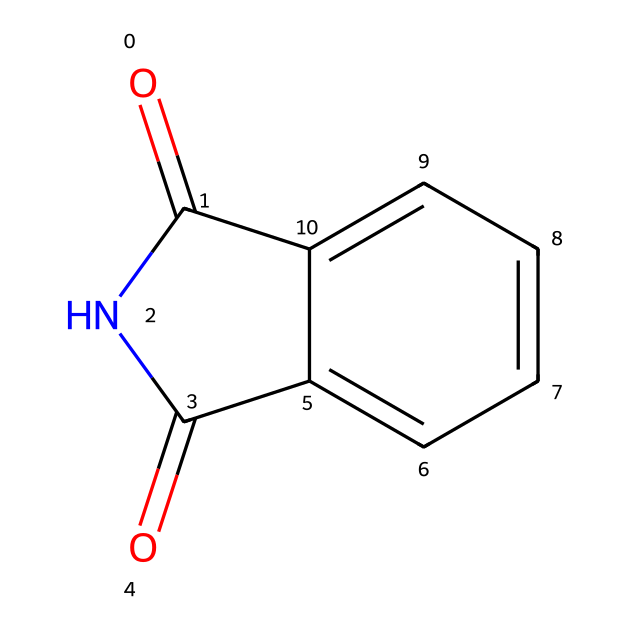What is the molecular formula of phthalimide? By analyzing the structure from the SMILES representation, O=C1NC(=O)c2ccccc21, we can count the atoms: there are 8 carbon (C), 5 hydrogen (H), 2 nitrogen (N), and 2 oxygen (O) atoms, leading to a formula of C8H5N2O2.
Answer: C8H5N2O2 How many rings are present in the structure? The structure indicates that there are two fused rings: the five-membered imide ring and the phenyl ring, which is a six-membered ring. This is evident from the connectivity indicated in the SMILES representation.
Answer: 2 What functional groups are present in phthalimide? Distinct functional groups identified in the structure include the imide (C=O and N) and the aromatic ring (the benzene part). The imide functional group is specifically indicated by the presence of nitrogen between two carbonyl (C=O) groups.
Answer: imide and aromatic What type of bonding is observed between the carbon and nitrogen atoms? In the structure, carbon atoms show double bonds with oxygen and form a single bond with the nitrogen atom. This single bond is characteristic of imide compounds, where nitrogen is bonded to carbon through a sigma bond.
Answer: single bond What is the hybridization state of the nitrogen in phthalimide? The nitrogen in phthalimide is involved in two single bonds (to carbon) and possesses a lone pair. This arrangement indicates that it utilizes sp2 hybridization, typically seen in imides that participate in resonance with nearby carbonyl groups.
Answer: sp2 Does phthalimide exhibit resonance? The structure allows for resonance due to the presence of the carbonyl groups adjacent to the nitrogen atom. This resonance can delocalize electrons, influencing stability and reactivity of the imide.
Answer: yes 